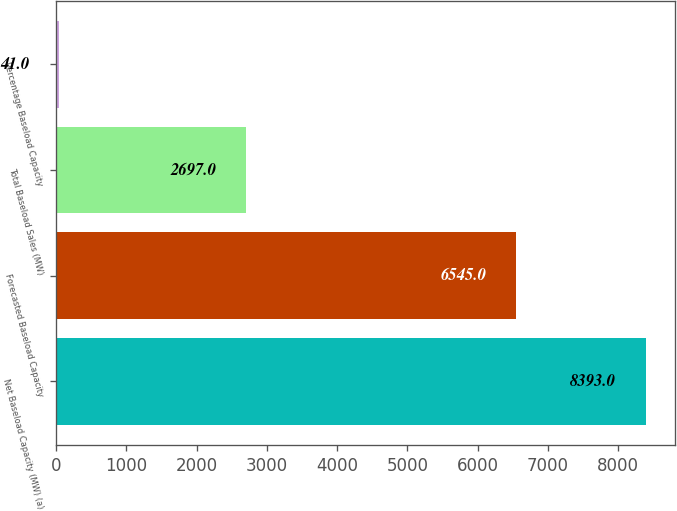<chart> <loc_0><loc_0><loc_500><loc_500><bar_chart><fcel>Net Baseload Capacity (MW) (a)<fcel>Forecasted Baseload Capacity<fcel>Total Baseload Sales (MW)<fcel>Percentage Baseload Capacity<nl><fcel>8393<fcel>6545<fcel>2697<fcel>41<nl></chart> 